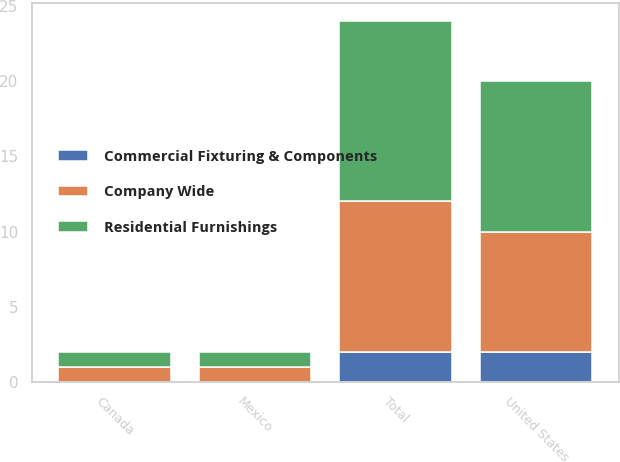Convert chart to OTSL. <chart><loc_0><loc_0><loc_500><loc_500><stacked_bar_chart><ecel><fcel>United States<fcel>Canada<fcel>Mexico<fcel>Total<nl><fcel>Residential Furnishings<fcel>10<fcel>1<fcel>1<fcel>12<nl><fcel>Commercial Fixturing & Components<fcel>2<fcel>0<fcel>0<fcel>2<nl><fcel>Company Wide<fcel>8<fcel>1<fcel>1<fcel>10<nl></chart> 